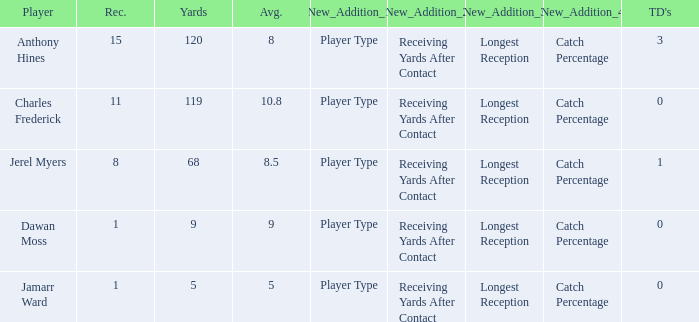What is the total Avg when TDs are 0 and Dawan Moss is a player? 0.0. 